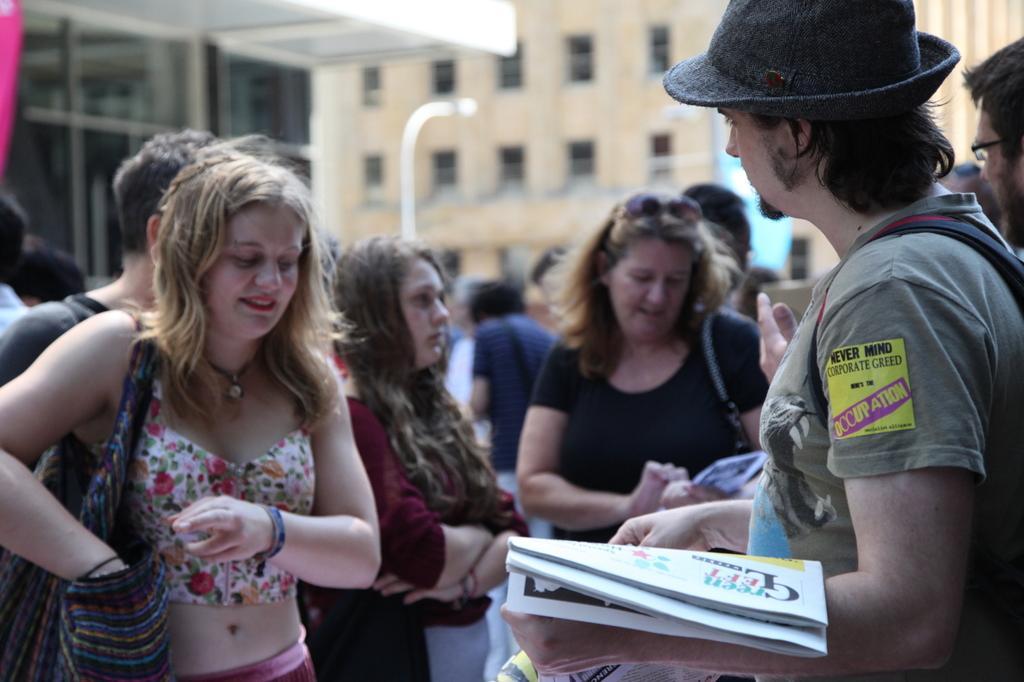Please provide a concise description of this image. In this picture we can see a group of people standing and in the background we can see buildings with windows. 